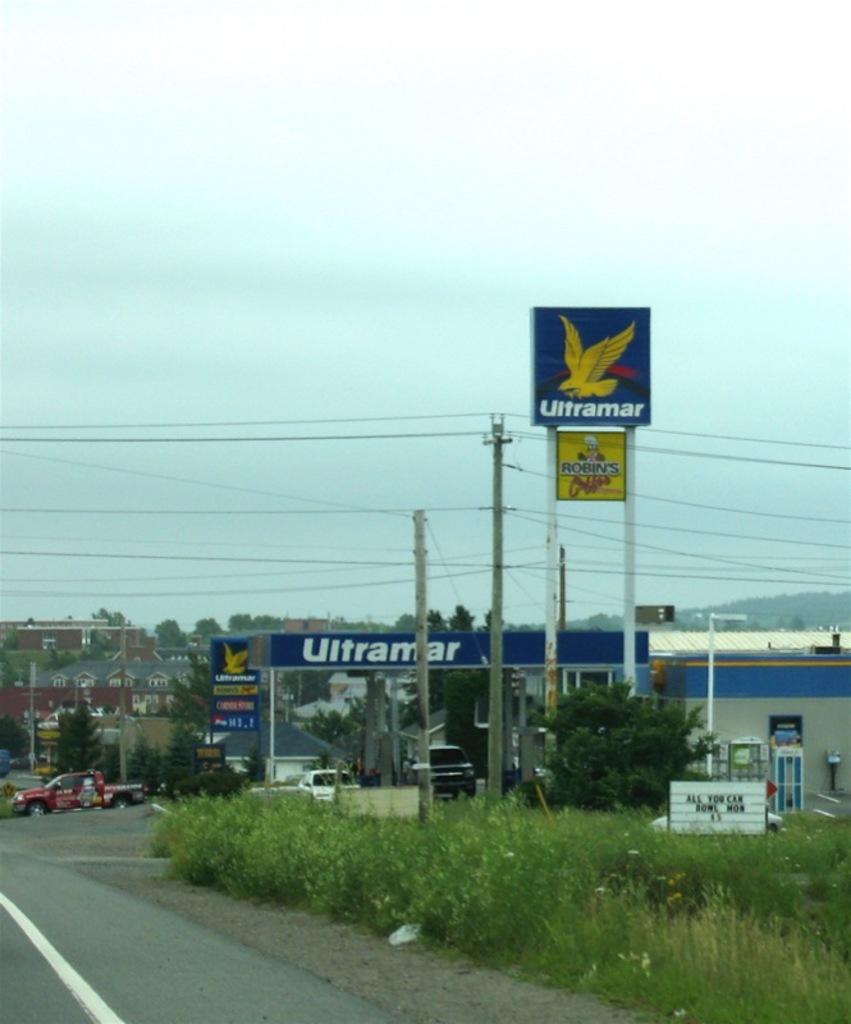What's the name of the coffee shop located by the gas station?
Give a very brief answer. Robins. 